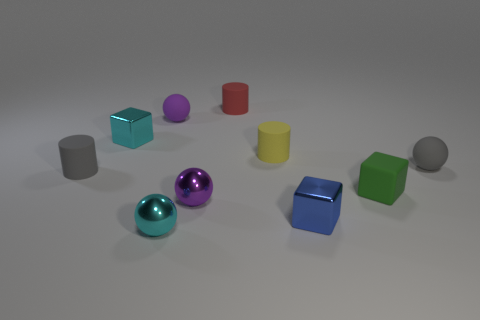Subtract all cubes. How many objects are left? 7 Subtract all yellow blocks. Subtract all small purple matte balls. How many objects are left? 9 Add 9 yellow rubber objects. How many yellow rubber objects are left? 10 Add 2 purple metal spheres. How many purple metal spheres exist? 3 Subtract 0 gray cubes. How many objects are left? 10 